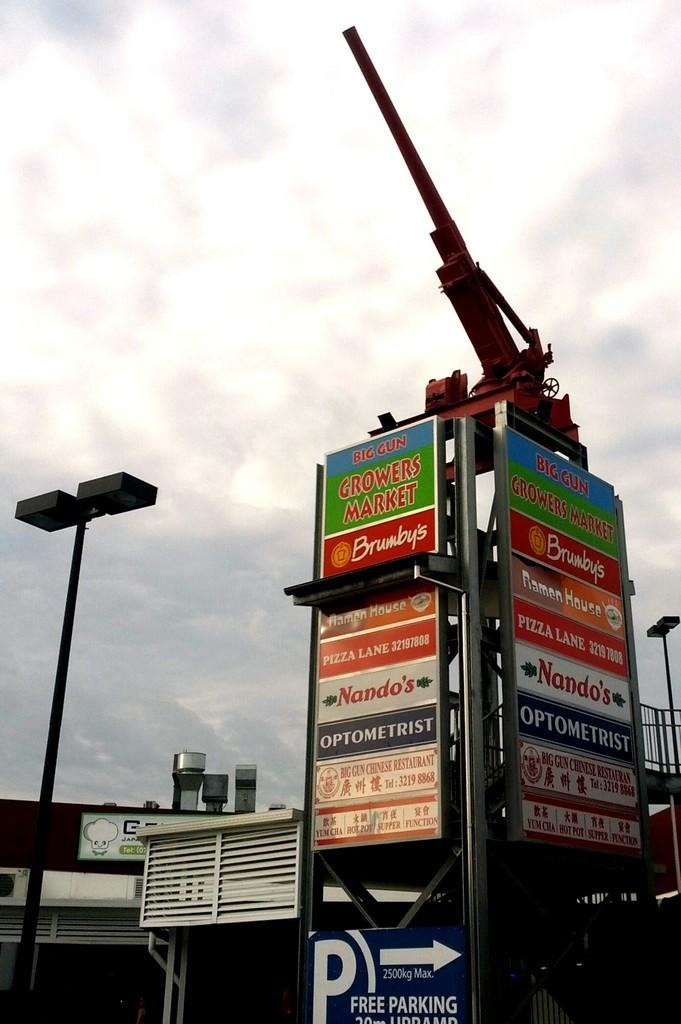What is the main subject of the image? The main subject of the image is the many buildings. Can you describe any specific objects or structures in the image? Yes, there is a pole with boards around it, and a canon is on top of the pole. What type of stamp can be seen on the canon in the image? There is no stamp present on the canon in the image. What type of insect is crawling on the buildings in the image? There are no insects visible in the image; it only features buildings, a pole, and a canon. 